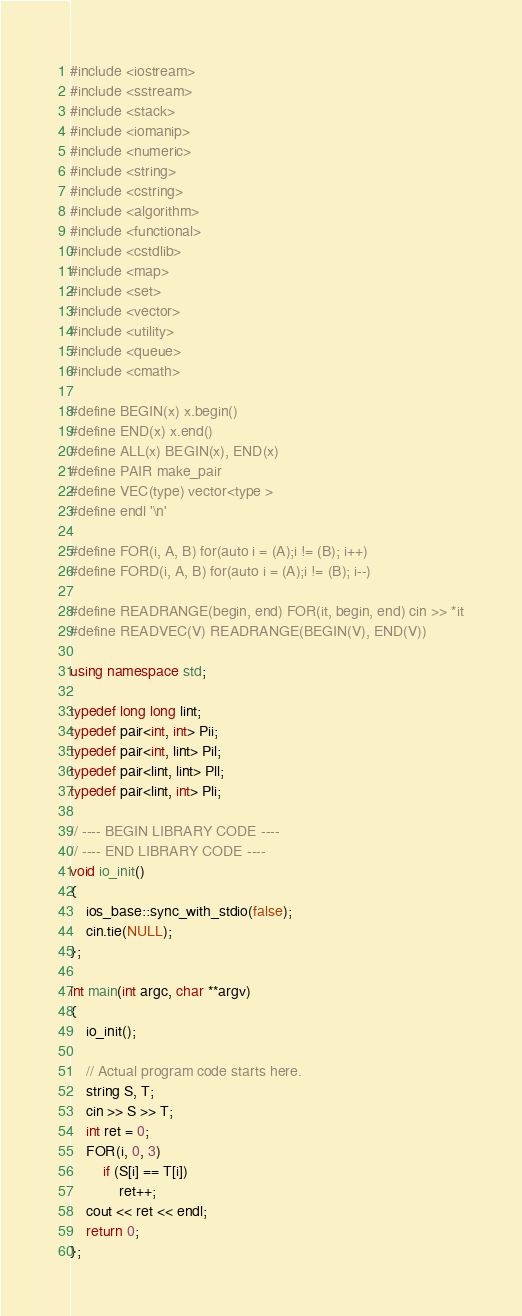Convert code to text. <code><loc_0><loc_0><loc_500><loc_500><_C++_>#include <iostream>
#include <sstream>
#include <stack>
#include <iomanip>
#include <numeric>
#include <string>
#include <cstring>
#include <algorithm>
#include <functional>
#include <cstdlib>
#include <map>
#include <set>
#include <vector>
#include <utility>
#include <queue>
#include <cmath>

#define BEGIN(x) x.begin()
#define END(x) x.end()
#define ALL(x) BEGIN(x), END(x)
#define PAIR make_pair
#define VEC(type) vector<type >
#define endl '\n'

#define FOR(i, A, B) for(auto i = (A);i != (B); i++)
#define FORD(i, A, B) for(auto i = (A);i != (B); i--)

#define READRANGE(begin, end) FOR(it, begin, end) cin >> *it
#define READVEC(V) READRANGE(BEGIN(V), END(V))

using namespace std;

typedef long long lint;
typedef pair<int, int> Pii;
typedef pair<int, lint> Pil;
typedef pair<lint, lint> Pll;
typedef pair<lint, int> Pli;

// ---- BEGIN LIBRARY CODE ----
// ---- END LIBRARY CODE ----
void io_init()
{
    ios_base::sync_with_stdio(false);
    cin.tie(NULL);
};

int main(int argc, char **argv)
{
    io_init();

    // Actual program code starts here.
    string S, T;
    cin >> S >> T;
    int ret = 0;
    FOR(i, 0, 3)
        if (S[i] == T[i])
            ret++;
    cout << ret << endl;
    return 0;
};
</code> 